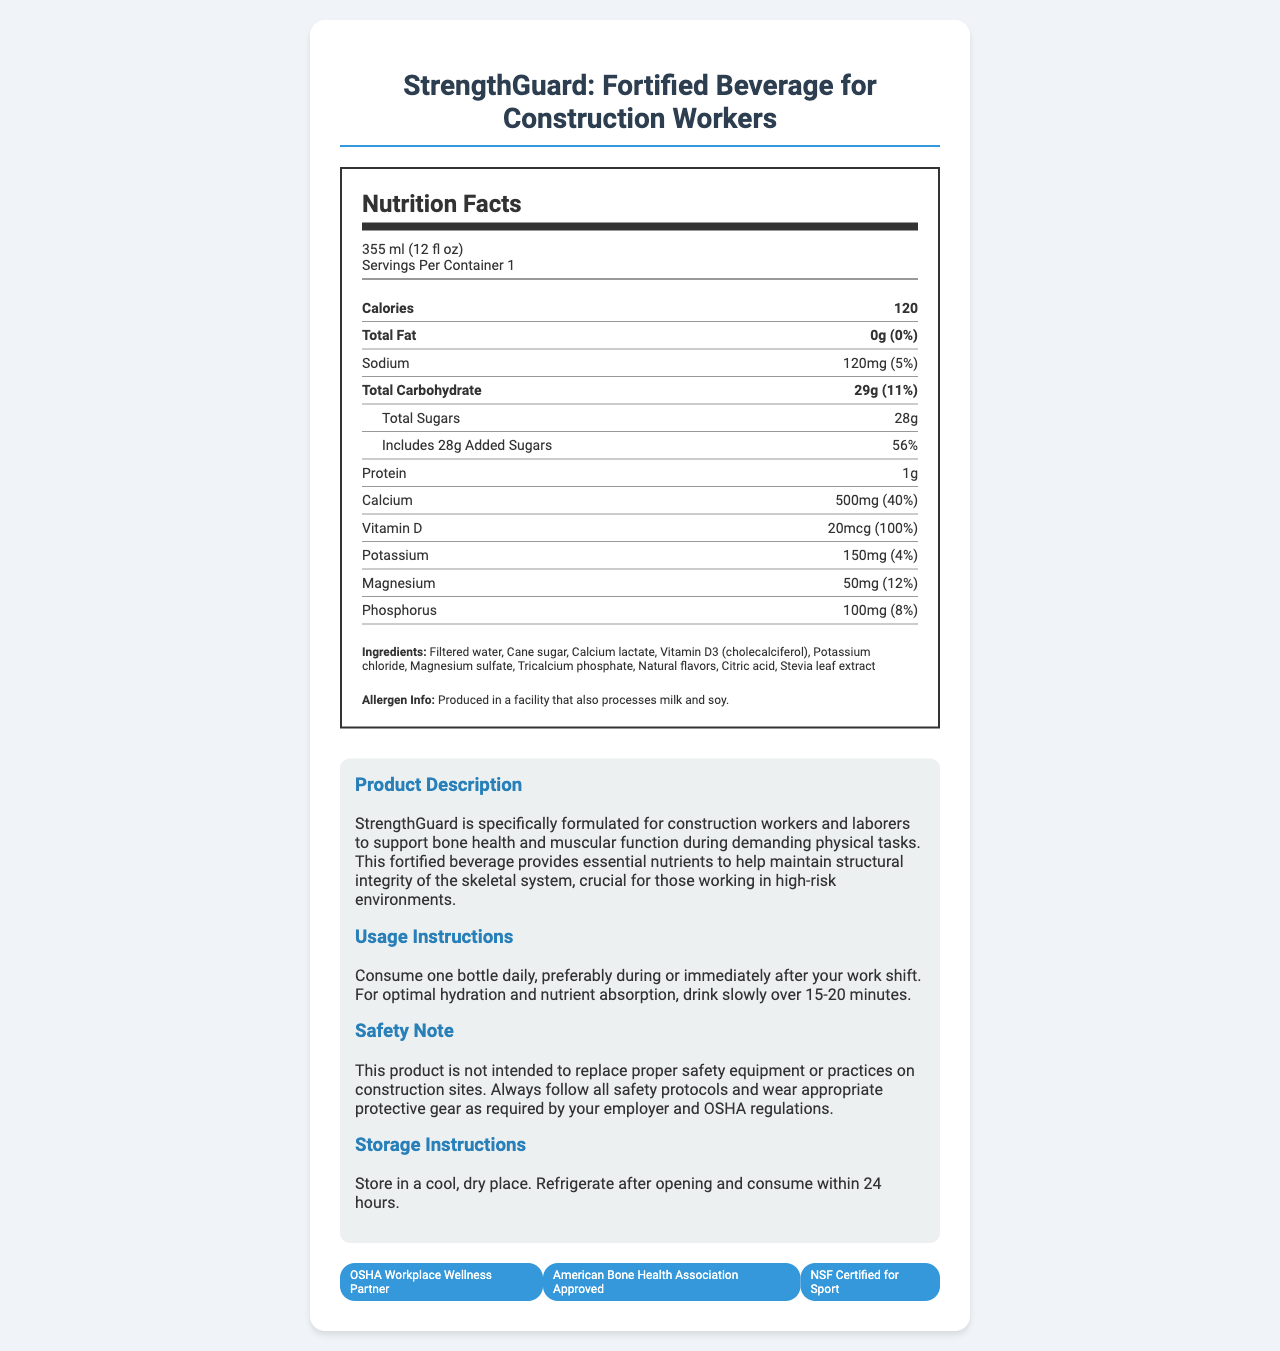what is the serving size of StrengthGuard? The serving size is mentioned at the beginning of the nutrition label.
Answer: 355 ml (12 fl oz) how much calcium is in one serving of StrengthGuard? The amount of calcium is listed under the nutrient section of the label.
Answer: 500mg how many grams of protein are in one serving? The protein content is stated under the nutrient section.
Answer: 1g what is the percentage of daily value for vitamin D? The percentage daily value for vitamin D is given in the vitamin D row.
Answer: 100% which organization certified this product as "OSHA Workplace Wellness Partner"? The certification section lists "OSHA Workplace Wellness Partner."
Answer: OSHA list three ingredients found in StrengthGuard. The ingredients are clearly listed at the end of the nutrition label.
Answer: Filtered water, Cane sugar, Calcium lactate how should you consume the beverage for optimal hydration and nutrient absorption? The usage instructions specify this method for optimal hydration and nutrient absorption.
Answer: Drink slowly over 15-20 minutes how many calories are in one serving of StrengthGuard? The calories are mentioned prominently in the nutrition label.
Answer: 120 what storage instructions are provided for StrengthGuard? The storage instructions are mentioned in the product information section.
Answer: Store in a cool, dry place. Refrigerate after opening and consume within 24 hours. how much added sugars does StrengthGuard have? The added sugars are mentioned under the total carbohydrate section.
Answer: 28g what nutrients are specifically highlighted to benefit bone strength and muscular function? A. Calcium and Vitamin D, B. Sodium and Magnesium, C. Protein and Potassium The product description highlights calcium and vitamin D for bone strength and muscular function.
Answer: A. Calcium and Vitamin D what is the total carbohydrate daily value percentage? A. 5% B. 11% C. 15% D. 20% The daily value percentage for total carbohydrates is given as 11%.
Answer: B. 11% does StrengthGuard provide any protein content? The document states that there is 1g of protein in StrengthGuard.
Answer: Yes was StrengthGuard produced in a facility that processes any allergens? The allergen info states that it was produced in a facility that also processes milk and soy.
Answer: Yes summarize the main idea of the document. The document describes the product's nutritional content, purpose, usage instructions, safety note, and certifications, focusing on its benefits for construction workers and laborers.
Answer: StrengthGuard is a fortified beverage designed specifically for construction workers to support bone health and muscular function. It contains essential nutrients such as calcium and vitamin D, is certified for sport, and provides hydration instructions for optimal nutrient absorption. how many calories from fat are present in StrengthGuard? The document provides the total fat content but does not specify how many calories are derived from fat.
Answer: Not enough information is this product intended to replace proper safety equipment on construction sites? The safety note explicitly states that it is not intended to replace safety equipment or practices.
Answer: No 